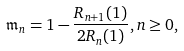Convert formula to latex. <formula><loc_0><loc_0><loc_500><loc_500>\mathfrak { m } _ { n } = 1 - \frac { R _ { n + 1 } ( 1 ) } { 2 R _ { n } ( 1 ) } , n \geq 0 ,</formula> 